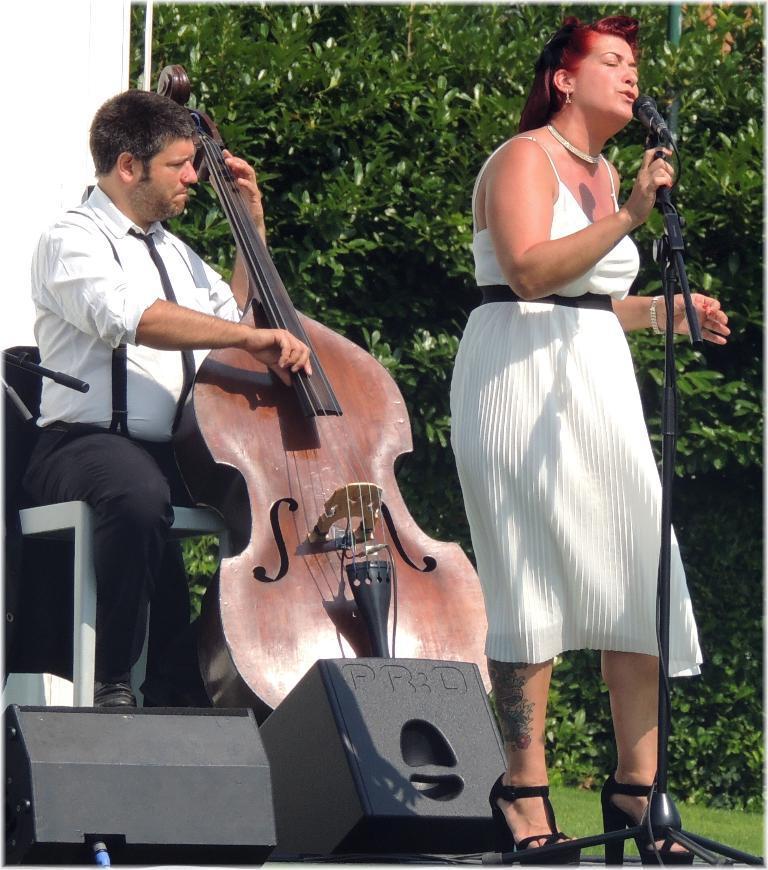Describe this image in one or two sentences. This image consist of two persons. The woman is standing and wearing a white dress. To the left, the man is sitting and wearing white shirt and playing a violin. At the bottom, there are two speakers. In the background, there are two trees and wall. 